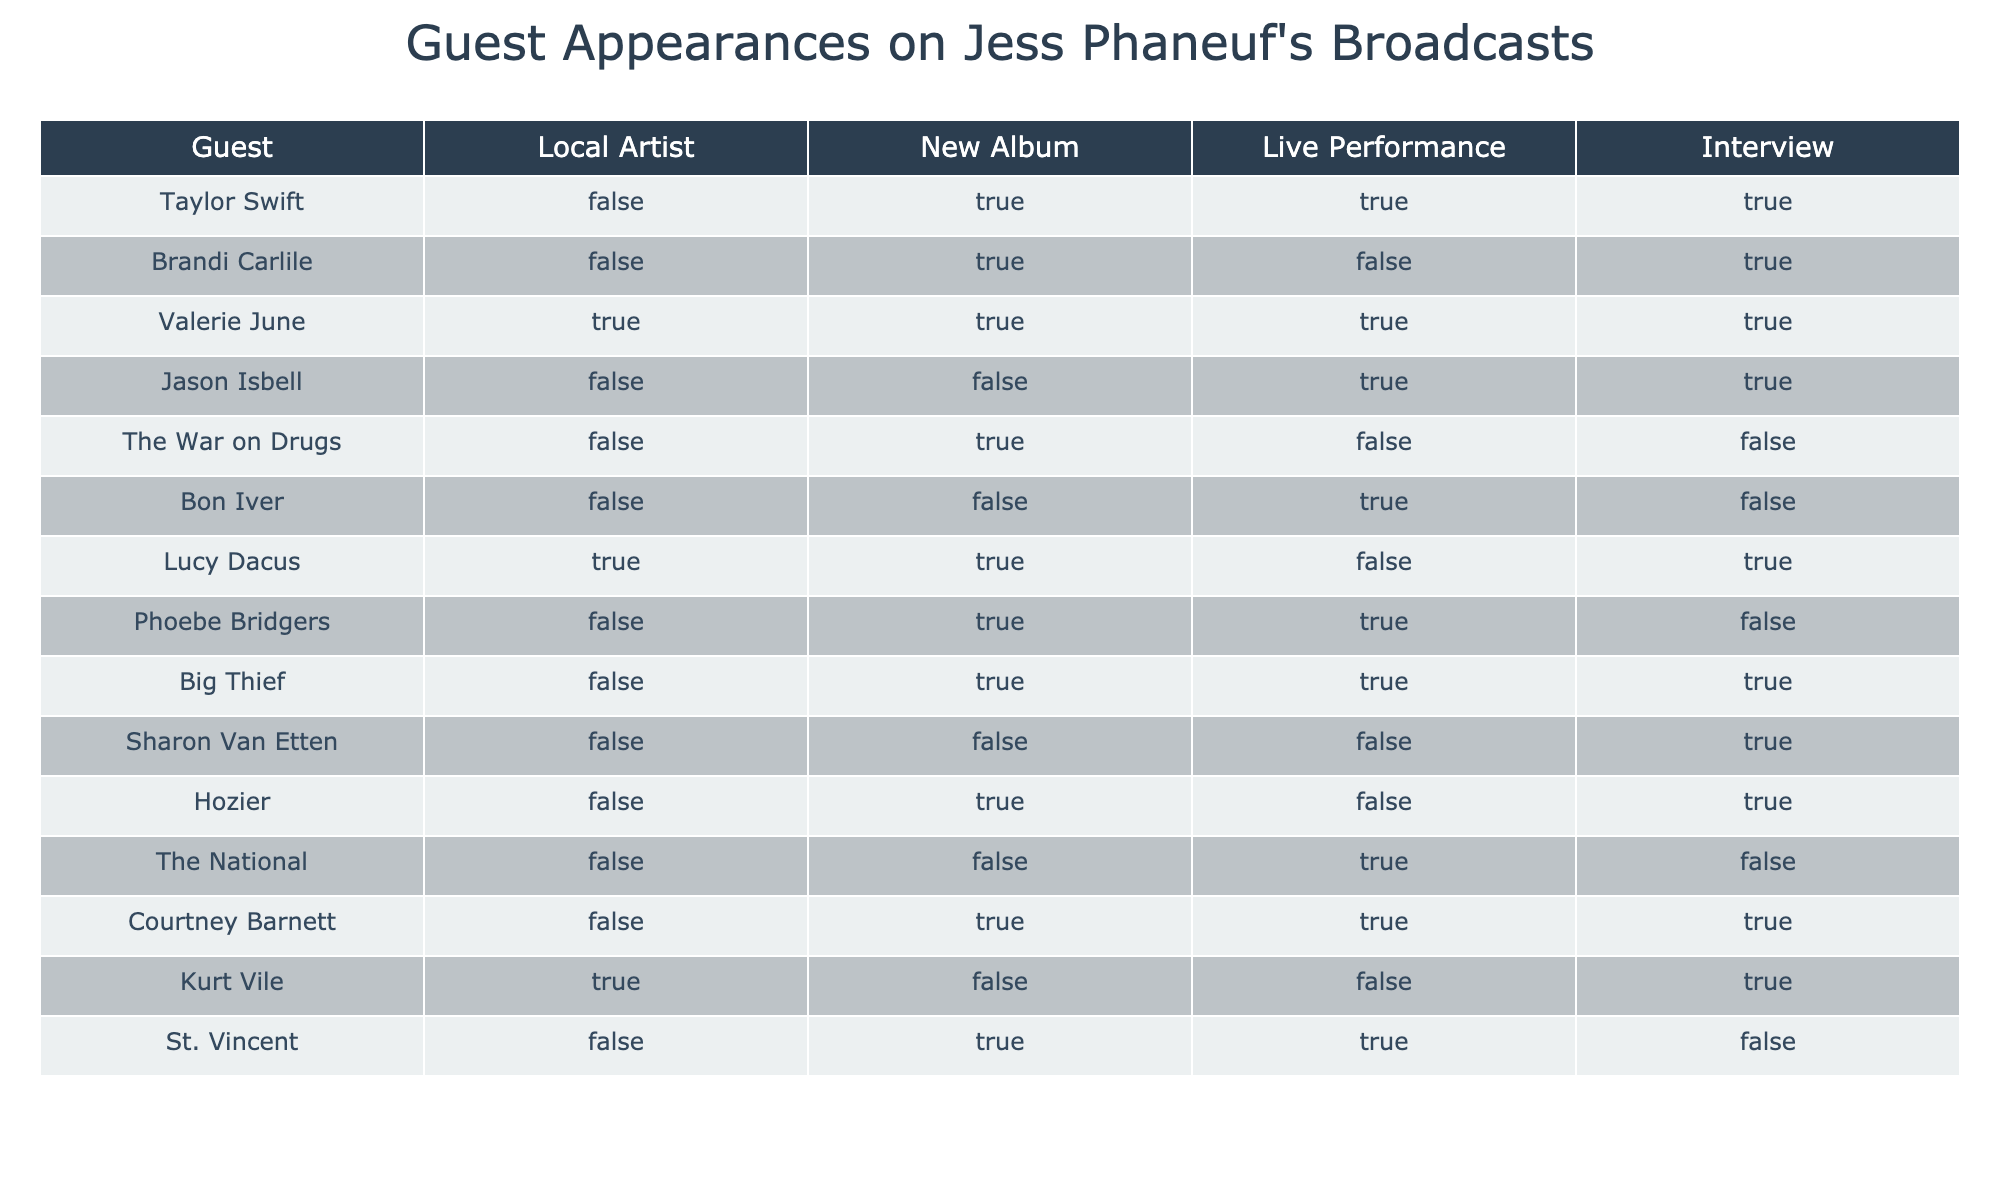What percentage of guests are local artists? There are 3 local artists (Valerie June, Lucy Dacus, Kurt Vile) out of 15 total guests. To find the percentage, divide the number of local artists by the total number of guests and multiply by 100: (3/15) * 100 = 20%.
Answer: 20% Which artist among the guests has a new album but did not perform live? The artist with a new album but did not perform live is The War on Drugs. In the table, their new album is marked TRUE, but live performance is marked FALSE.
Answer: The War on Drugs Is Phoebe Bridgers a local artist? In the table, the column for "Local Artist" is marked FALSE for Phoebe Bridgers. Thus, she is not a local artist.
Answer: No How many guests were interviewed but did not release a new album? The guests who were interviewed (Interview TRUE) and did not release a new album (New Album FALSE) are Jason Isbell, Bon Iver, and Sharon Van Etten. Counting these gives us a total of 3 guests.
Answer: 3 What is the total number of guests that are both local artists and have a new album? The local artists with a new album are Valerie June and Lucy Dacus, making a total of 2. To find this, we look for rows where both "Local Artist" and "New Album" are TRUE.
Answer: 2 For how many guests was there a live performance and an interview, but no new album released? By checking the table, we find that only Jason Isbell and Sharon Van Etten fit this criterion, leading to a total of 2 guests where live performance and interview are TRUE, but new album is FALSE.
Answer: 2 Are there any guests who are local artists and also performed live? Yes, Valerie June and Lucy Dacus are both local artists who performed live; their respective rows show TRUE for both "Local Artist" and "Live Performance".
Answer: Yes What is the average number of guests who have a new album compared to those who performed live? There are 10 guests with a new album (counting all TRUE values for "New Album") and 8 guests who performed live. To calculate the average, we divide the total number of TRUE values: (10 + 8) / 2 = 9.
Answer: 9 